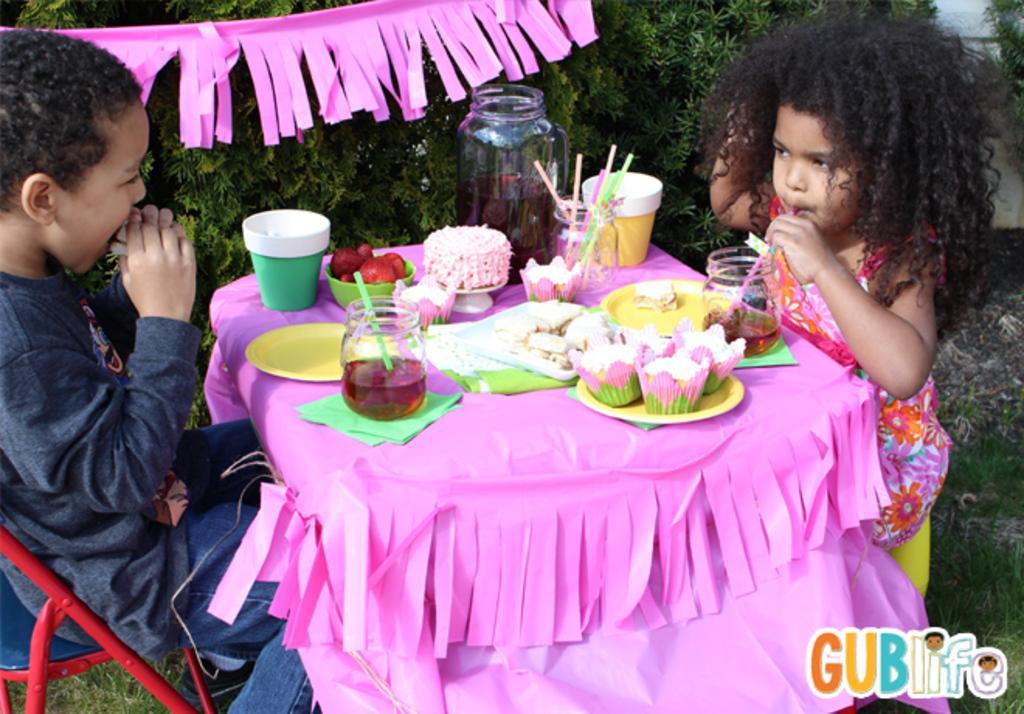Describe this image in one or two sentences. In this picture we can see two children sitting on the chairs. This is grass. And there is a table. On the table there is some food, plates, and cups. On the background we can see some plants. And this is the ribbon. 